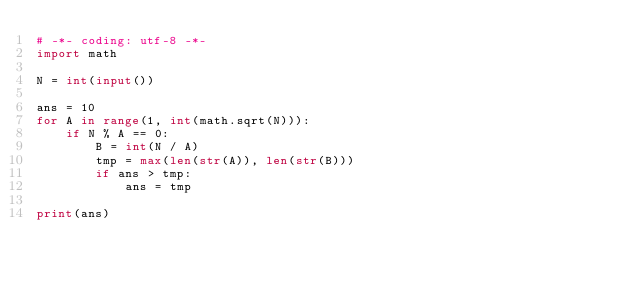<code> <loc_0><loc_0><loc_500><loc_500><_Python_># -*- coding: utf-8 -*-
import math

N = int(input())

ans = 10
for A in range(1, int(math.sqrt(N))):
    if N % A == 0:
        B = int(N / A)
        tmp = max(len(str(A)), len(str(B)))
        if ans > tmp:
            ans = tmp

print(ans)
</code> 